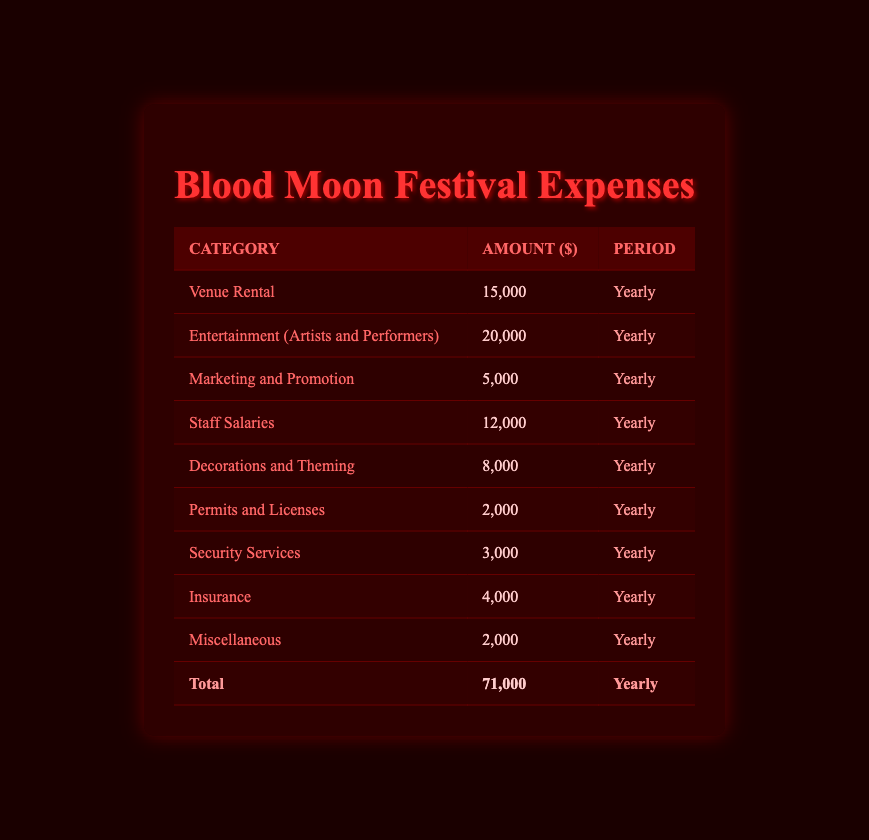What is the total expense for the Blood Moon Festival? The total expense is calculated by summing all the individual expenses listed in the table. Adding them together: 15000 + 20000 + 5000 + 12000 + 8000 + 2000 + 3000 + 4000 + 2000 = 71000.
Answer: 71000 How much is allocated for Entertainment? The Entertainment expense for the festival is explicitly listed in the table as 20000.
Answer: 20000 Is the cost for Permits and Licenses higher than that for Marketing and Promotion? The cost for Permits and Licenses is 2000 while Marketing and Promotion is 5000. Since 2000 is less than 5000, the statement is false.
Answer: No What percentage of the total expense is spent on Security Services? The amount for Security Services is 3000. To find the percentage of the total expense, we calculate (3000/71000) * 100, which is approximately 4.23%.
Answer: 4.23% What are the categories of expenses that exceed 10000? We review each expense in the table and find that Venue Rental (15000) and Entertainment (20000) are greater than 10000.
Answer: Venue Rental and Entertainment What is the difference between the highest and lowest expense categories? The highest expense is Entertainment at 20000 and the lowest is Permits and Licenses at 2000. The difference is calculated as 20000 - 2000 = 18000.
Answer: 18000 If you add together the costs of Decorations and Theming and Staff Salaries, what do you get? The cost for Decorations and Theming is 8000 and for Staff Salaries is 12000. Adding these two figures gives 8000 + 12000 = 20000.
Answer: 20000 Are there more expenses related to security than marketing? There's one entry for Security Services (3000) and one for Marketing and Promotion (5000). Since both have just a single expense, the comparison is equal regarding the number of entries, but Marketing has a higher cost. Therefore, the answer focuses on the quantity rather than cost.
Answer: No 